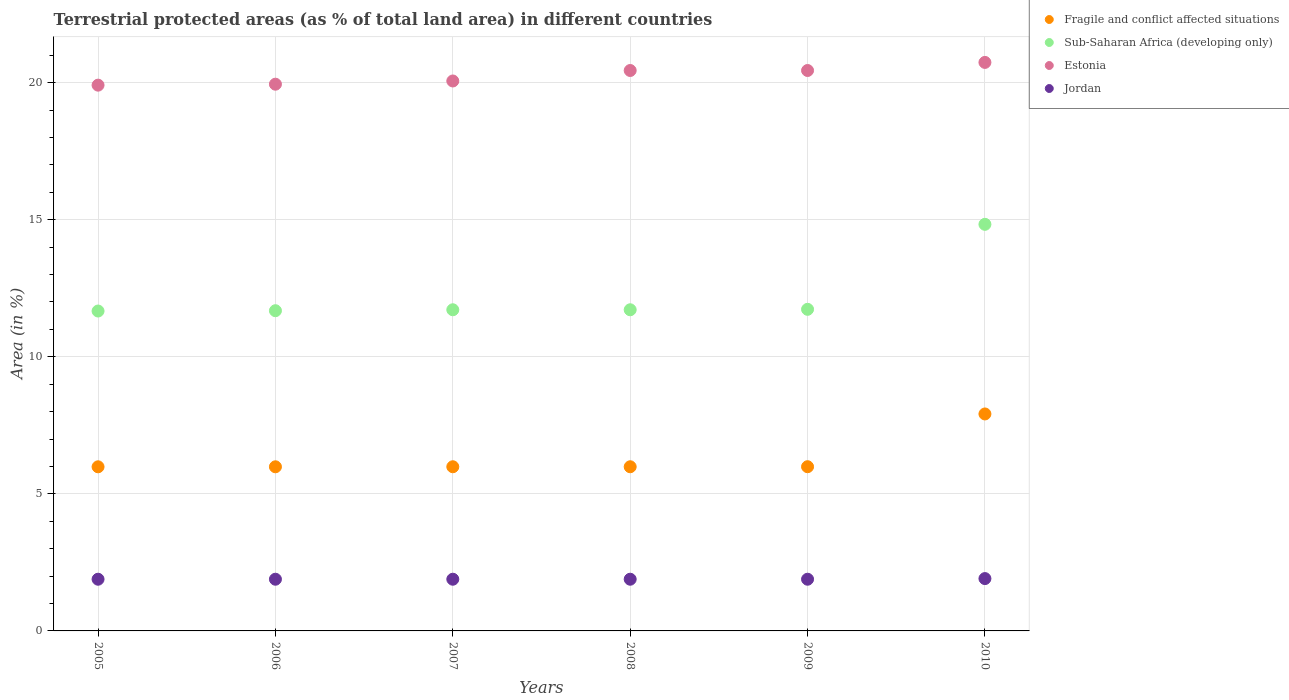How many different coloured dotlines are there?
Provide a succinct answer. 4. What is the percentage of terrestrial protected land in Sub-Saharan Africa (developing only) in 2006?
Ensure brevity in your answer.  11.68. Across all years, what is the maximum percentage of terrestrial protected land in Jordan?
Your answer should be very brief. 1.91. Across all years, what is the minimum percentage of terrestrial protected land in Estonia?
Provide a succinct answer. 19.91. In which year was the percentage of terrestrial protected land in Sub-Saharan Africa (developing only) maximum?
Your response must be concise. 2010. In which year was the percentage of terrestrial protected land in Jordan minimum?
Offer a very short reply. 2005. What is the total percentage of terrestrial protected land in Fragile and conflict affected situations in the graph?
Your answer should be compact. 37.85. What is the difference between the percentage of terrestrial protected land in Sub-Saharan Africa (developing only) in 2006 and that in 2009?
Ensure brevity in your answer.  -0.05. What is the difference between the percentage of terrestrial protected land in Sub-Saharan Africa (developing only) in 2005 and the percentage of terrestrial protected land in Fragile and conflict affected situations in 2009?
Offer a terse response. 5.68. What is the average percentage of terrestrial protected land in Estonia per year?
Offer a very short reply. 20.25. In the year 2008, what is the difference between the percentage of terrestrial protected land in Fragile and conflict affected situations and percentage of terrestrial protected land in Jordan?
Keep it short and to the point. 4.1. In how many years, is the percentage of terrestrial protected land in Fragile and conflict affected situations greater than 20 %?
Your response must be concise. 0. What is the ratio of the percentage of terrestrial protected land in Sub-Saharan Africa (developing only) in 2006 to that in 2009?
Your answer should be very brief. 1. Is the percentage of terrestrial protected land in Jordan in 2006 less than that in 2008?
Your answer should be very brief. No. What is the difference between the highest and the second highest percentage of terrestrial protected land in Fragile and conflict affected situations?
Offer a terse response. 1.92. What is the difference between the highest and the lowest percentage of terrestrial protected land in Jordan?
Your answer should be compact. 0.02. In how many years, is the percentage of terrestrial protected land in Fragile and conflict affected situations greater than the average percentage of terrestrial protected land in Fragile and conflict affected situations taken over all years?
Ensure brevity in your answer.  1. Is the sum of the percentage of terrestrial protected land in Fragile and conflict affected situations in 2009 and 2010 greater than the maximum percentage of terrestrial protected land in Sub-Saharan Africa (developing only) across all years?
Keep it short and to the point. No. Is it the case that in every year, the sum of the percentage of terrestrial protected land in Estonia and percentage of terrestrial protected land in Sub-Saharan Africa (developing only)  is greater than the sum of percentage of terrestrial protected land in Fragile and conflict affected situations and percentage of terrestrial protected land in Jordan?
Ensure brevity in your answer.  Yes. Does the percentage of terrestrial protected land in Fragile and conflict affected situations monotonically increase over the years?
Your answer should be very brief. No. Is the percentage of terrestrial protected land in Jordan strictly greater than the percentage of terrestrial protected land in Sub-Saharan Africa (developing only) over the years?
Offer a very short reply. No. Is the percentage of terrestrial protected land in Fragile and conflict affected situations strictly less than the percentage of terrestrial protected land in Jordan over the years?
Your response must be concise. No. How many years are there in the graph?
Provide a succinct answer. 6. Does the graph contain any zero values?
Ensure brevity in your answer.  No. How many legend labels are there?
Provide a succinct answer. 4. What is the title of the graph?
Your answer should be compact. Terrestrial protected areas (as % of total land area) in different countries. What is the label or title of the Y-axis?
Provide a succinct answer. Area (in %). What is the Area (in %) of Fragile and conflict affected situations in 2005?
Your response must be concise. 5.99. What is the Area (in %) in Sub-Saharan Africa (developing only) in 2005?
Your answer should be compact. 11.67. What is the Area (in %) of Estonia in 2005?
Keep it short and to the point. 19.91. What is the Area (in %) of Jordan in 2005?
Keep it short and to the point. 1.89. What is the Area (in %) in Fragile and conflict affected situations in 2006?
Your answer should be very brief. 5.99. What is the Area (in %) of Sub-Saharan Africa (developing only) in 2006?
Your answer should be very brief. 11.68. What is the Area (in %) in Estonia in 2006?
Your response must be concise. 19.94. What is the Area (in %) in Jordan in 2006?
Provide a short and direct response. 1.89. What is the Area (in %) of Fragile and conflict affected situations in 2007?
Your response must be concise. 5.99. What is the Area (in %) of Sub-Saharan Africa (developing only) in 2007?
Offer a terse response. 11.71. What is the Area (in %) of Estonia in 2007?
Provide a succinct answer. 20.06. What is the Area (in %) of Jordan in 2007?
Your answer should be compact. 1.89. What is the Area (in %) of Fragile and conflict affected situations in 2008?
Offer a terse response. 5.99. What is the Area (in %) of Sub-Saharan Africa (developing only) in 2008?
Your response must be concise. 11.71. What is the Area (in %) of Estonia in 2008?
Give a very brief answer. 20.44. What is the Area (in %) of Jordan in 2008?
Provide a short and direct response. 1.89. What is the Area (in %) in Fragile and conflict affected situations in 2009?
Provide a succinct answer. 5.99. What is the Area (in %) in Sub-Saharan Africa (developing only) in 2009?
Offer a very short reply. 11.73. What is the Area (in %) of Estonia in 2009?
Provide a succinct answer. 20.44. What is the Area (in %) in Jordan in 2009?
Provide a succinct answer. 1.89. What is the Area (in %) of Fragile and conflict affected situations in 2010?
Ensure brevity in your answer.  7.91. What is the Area (in %) in Sub-Saharan Africa (developing only) in 2010?
Your answer should be compact. 14.83. What is the Area (in %) of Estonia in 2010?
Provide a short and direct response. 20.74. What is the Area (in %) in Jordan in 2010?
Your answer should be very brief. 1.91. Across all years, what is the maximum Area (in %) in Fragile and conflict affected situations?
Your answer should be very brief. 7.91. Across all years, what is the maximum Area (in %) of Sub-Saharan Africa (developing only)?
Your answer should be very brief. 14.83. Across all years, what is the maximum Area (in %) of Estonia?
Offer a terse response. 20.74. Across all years, what is the maximum Area (in %) in Jordan?
Offer a terse response. 1.91. Across all years, what is the minimum Area (in %) of Fragile and conflict affected situations?
Your answer should be compact. 5.99. Across all years, what is the minimum Area (in %) in Sub-Saharan Africa (developing only)?
Provide a short and direct response. 11.67. Across all years, what is the minimum Area (in %) of Estonia?
Give a very brief answer. 19.91. Across all years, what is the minimum Area (in %) of Jordan?
Your response must be concise. 1.89. What is the total Area (in %) in Fragile and conflict affected situations in the graph?
Give a very brief answer. 37.85. What is the total Area (in %) in Sub-Saharan Africa (developing only) in the graph?
Give a very brief answer. 73.34. What is the total Area (in %) in Estonia in the graph?
Offer a very short reply. 121.53. What is the total Area (in %) in Jordan in the graph?
Your response must be concise. 11.34. What is the difference between the Area (in %) in Fragile and conflict affected situations in 2005 and that in 2006?
Provide a short and direct response. -0. What is the difference between the Area (in %) in Sub-Saharan Africa (developing only) in 2005 and that in 2006?
Ensure brevity in your answer.  -0.01. What is the difference between the Area (in %) in Estonia in 2005 and that in 2006?
Make the answer very short. -0.03. What is the difference between the Area (in %) of Jordan in 2005 and that in 2006?
Offer a very short reply. 0. What is the difference between the Area (in %) in Fragile and conflict affected situations in 2005 and that in 2007?
Make the answer very short. -0. What is the difference between the Area (in %) of Sub-Saharan Africa (developing only) in 2005 and that in 2007?
Provide a succinct answer. -0.05. What is the difference between the Area (in %) of Estonia in 2005 and that in 2007?
Provide a short and direct response. -0.15. What is the difference between the Area (in %) in Jordan in 2005 and that in 2007?
Keep it short and to the point. 0. What is the difference between the Area (in %) in Fragile and conflict affected situations in 2005 and that in 2008?
Give a very brief answer. -0. What is the difference between the Area (in %) in Sub-Saharan Africa (developing only) in 2005 and that in 2008?
Give a very brief answer. -0.05. What is the difference between the Area (in %) of Estonia in 2005 and that in 2008?
Provide a succinct answer. -0.53. What is the difference between the Area (in %) in Jordan in 2005 and that in 2008?
Ensure brevity in your answer.  0. What is the difference between the Area (in %) in Fragile and conflict affected situations in 2005 and that in 2009?
Give a very brief answer. -0. What is the difference between the Area (in %) in Sub-Saharan Africa (developing only) in 2005 and that in 2009?
Offer a very short reply. -0.06. What is the difference between the Area (in %) of Estonia in 2005 and that in 2009?
Your response must be concise. -0.53. What is the difference between the Area (in %) of Fragile and conflict affected situations in 2005 and that in 2010?
Offer a terse response. -1.93. What is the difference between the Area (in %) of Sub-Saharan Africa (developing only) in 2005 and that in 2010?
Provide a succinct answer. -3.16. What is the difference between the Area (in %) in Estonia in 2005 and that in 2010?
Provide a succinct answer. -0.83. What is the difference between the Area (in %) of Jordan in 2005 and that in 2010?
Your response must be concise. -0.02. What is the difference between the Area (in %) of Fragile and conflict affected situations in 2006 and that in 2007?
Ensure brevity in your answer.  -0. What is the difference between the Area (in %) of Sub-Saharan Africa (developing only) in 2006 and that in 2007?
Offer a terse response. -0.03. What is the difference between the Area (in %) in Estonia in 2006 and that in 2007?
Offer a terse response. -0.12. What is the difference between the Area (in %) of Jordan in 2006 and that in 2007?
Offer a terse response. 0. What is the difference between the Area (in %) in Fragile and conflict affected situations in 2006 and that in 2008?
Make the answer very short. -0. What is the difference between the Area (in %) of Sub-Saharan Africa (developing only) in 2006 and that in 2008?
Your answer should be very brief. -0.03. What is the difference between the Area (in %) in Estonia in 2006 and that in 2008?
Your response must be concise. -0.5. What is the difference between the Area (in %) in Fragile and conflict affected situations in 2006 and that in 2009?
Your answer should be compact. -0. What is the difference between the Area (in %) of Sub-Saharan Africa (developing only) in 2006 and that in 2009?
Your answer should be compact. -0.05. What is the difference between the Area (in %) in Estonia in 2006 and that in 2009?
Your answer should be very brief. -0.5. What is the difference between the Area (in %) in Fragile and conflict affected situations in 2006 and that in 2010?
Offer a very short reply. -1.93. What is the difference between the Area (in %) in Sub-Saharan Africa (developing only) in 2006 and that in 2010?
Keep it short and to the point. -3.15. What is the difference between the Area (in %) in Estonia in 2006 and that in 2010?
Your response must be concise. -0.79. What is the difference between the Area (in %) of Jordan in 2006 and that in 2010?
Your answer should be very brief. -0.02. What is the difference between the Area (in %) in Fragile and conflict affected situations in 2007 and that in 2008?
Offer a very short reply. 0. What is the difference between the Area (in %) of Estonia in 2007 and that in 2008?
Provide a short and direct response. -0.38. What is the difference between the Area (in %) in Fragile and conflict affected situations in 2007 and that in 2009?
Your answer should be compact. -0. What is the difference between the Area (in %) of Sub-Saharan Africa (developing only) in 2007 and that in 2009?
Your answer should be very brief. -0.02. What is the difference between the Area (in %) in Estonia in 2007 and that in 2009?
Offer a very short reply. -0.38. What is the difference between the Area (in %) of Fragile and conflict affected situations in 2007 and that in 2010?
Give a very brief answer. -1.93. What is the difference between the Area (in %) in Sub-Saharan Africa (developing only) in 2007 and that in 2010?
Your answer should be very brief. -3.12. What is the difference between the Area (in %) in Estonia in 2007 and that in 2010?
Keep it short and to the point. -0.68. What is the difference between the Area (in %) in Jordan in 2007 and that in 2010?
Your response must be concise. -0.02. What is the difference between the Area (in %) in Fragile and conflict affected situations in 2008 and that in 2009?
Keep it short and to the point. -0. What is the difference between the Area (in %) in Sub-Saharan Africa (developing only) in 2008 and that in 2009?
Offer a very short reply. -0.02. What is the difference between the Area (in %) in Jordan in 2008 and that in 2009?
Offer a terse response. 0. What is the difference between the Area (in %) of Fragile and conflict affected situations in 2008 and that in 2010?
Offer a very short reply. -1.93. What is the difference between the Area (in %) in Sub-Saharan Africa (developing only) in 2008 and that in 2010?
Provide a succinct answer. -3.12. What is the difference between the Area (in %) of Estonia in 2008 and that in 2010?
Give a very brief answer. -0.29. What is the difference between the Area (in %) in Jordan in 2008 and that in 2010?
Keep it short and to the point. -0.02. What is the difference between the Area (in %) in Fragile and conflict affected situations in 2009 and that in 2010?
Make the answer very short. -1.92. What is the difference between the Area (in %) of Sub-Saharan Africa (developing only) in 2009 and that in 2010?
Your answer should be very brief. -3.1. What is the difference between the Area (in %) in Estonia in 2009 and that in 2010?
Provide a short and direct response. -0.29. What is the difference between the Area (in %) in Jordan in 2009 and that in 2010?
Provide a succinct answer. -0.02. What is the difference between the Area (in %) in Fragile and conflict affected situations in 2005 and the Area (in %) in Sub-Saharan Africa (developing only) in 2006?
Your response must be concise. -5.69. What is the difference between the Area (in %) of Fragile and conflict affected situations in 2005 and the Area (in %) of Estonia in 2006?
Offer a terse response. -13.96. What is the difference between the Area (in %) in Fragile and conflict affected situations in 2005 and the Area (in %) in Jordan in 2006?
Give a very brief answer. 4.1. What is the difference between the Area (in %) in Sub-Saharan Africa (developing only) in 2005 and the Area (in %) in Estonia in 2006?
Provide a short and direct response. -8.27. What is the difference between the Area (in %) in Sub-Saharan Africa (developing only) in 2005 and the Area (in %) in Jordan in 2006?
Ensure brevity in your answer.  9.78. What is the difference between the Area (in %) in Estonia in 2005 and the Area (in %) in Jordan in 2006?
Keep it short and to the point. 18.02. What is the difference between the Area (in %) of Fragile and conflict affected situations in 2005 and the Area (in %) of Sub-Saharan Africa (developing only) in 2007?
Your response must be concise. -5.73. What is the difference between the Area (in %) in Fragile and conflict affected situations in 2005 and the Area (in %) in Estonia in 2007?
Your answer should be compact. -14.07. What is the difference between the Area (in %) in Fragile and conflict affected situations in 2005 and the Area (in %) in Jordan in 2007?
Give a very brief answer. 4.1. What is the difference between the Area (in %) of Sub-Saharan Africa (developing only) in 2005 and the Area (in %) of Estonia in 2007?
Provide a succinct answer. -8.39. What is the difference between the Area (in %) in Sub-Saharan Africa (developing only) in 2005 and the Area (in %) in Jordan in 2007?
Offer a terse response. 9.78. What is the difference between the Area (in %) of Estonia in 2005 and the Area (in %) of Jordan in 2007?
Ensure brevity in your answer.  18.02. What is the difference between the Area (in %) in Fragile and conflict affected situations in 2005 and the Area (in %) in Sub-Saharan Africa (developing only) in 2008?
Give a very brief answer. -5.73. What is the difference between the Area (in %) of Fragile and conflict affected situations in 2005 and the Area (in %) of Estonia in 2008?
Your answer should be very brief. -14.46. What is the difference between the Area (in %) in Fragile and conflict affected situations in 2005 and the Area (in %) in Jordan in 2008?
Ensure brevity in your answer.  4.1. What is the difference between the Area (in %) in Sub-Saharan Africa (developing only) in 2005 and the Area (in %) in Estonia in 2008?
Your response must be concise. -8.77. What is the difference between the Area (in %) of Sub-Saharan Africa (developing only) in 2005 and the Area (in %) of Jordan in 2008?
Provide a short and direct response. 9.78. What is the difference between the Area (in %) of Estonia in 2005 and the Area (in %) of Jordan in 2008?
Your answer should be very brief. 18.02. What is the difference between the Area (in %) of Fragile and conflict affected situations in 2005 and the Area (in %) of Sub-Saharan Africa (developing only) in 2009?
Give a very brief answer. -5.74. What is the difference between the Area (in %) of Fragile and conflict affected situations in 2005 and the Area (in %) of Estonia in 2009?
Offer a terse response. -14.46. What is the difference between the Area (in %) of Fragile and conflict affected situations in 2005 and the Area (in %) of Jordan in 2009?
Ensure brevity in your answer.  4.1. What is the difference between the Area (in %) of Sub-Saharan Africa (developing only) in 2005 and the Area (in %) of Estonia in 2009?
Provide a succinct answer. -8.77. What is the difference between the Area (in %) in Sub-Saharan Africa (developing only) in 2005 and the Area (in %) in Jordan in 2009?
Your answer should be very brief. 9.78. What is the difference between the Area (in %) of Estonia in 2005 and the Area (in %) of Jordan in 2009?
Provide a short and direct response. 18.02. What is the difference between the Area (in %) of Fragile and conflict affected situations in 2005 and the Area (in %) of Sub-Saharan Africa (developing only) in 2010?
Keep it short and to the point. -8.84. What is the difference between the Area (in %) of Fragile and conflict affected situations in 2005 and the Area (in %) of Estonia in 2010?
Offer a terse response. -14.75. What is the difference between the Area (in %) of Fragile and conflict affected situations in 2005 and the Area (in %) of Jordan in 2010?
Ensure brevity in your answer.  4.08. What is the difference between the Area (in %) in Sub-Saharan Africa (developing only) in 2005 and the Area (in %) in Estonia in 2010?
Ensure brevity in your answer.  -9.07. What is the difference between the Area (in %) of Sub-Saharan Africa (developing only) in 2005 and the Area (in %) of Jordan in 2010?
Offer a very short reply. 9.76. What is the difference between the Area (in %) of Estonia in 2005 and the Area (in %) of Jordan in 2010?
Your response must be concise. 18. What is the difference between the Area (in %) of Fragile and conflict affected situations in 2006 and the Area (in %) of Sub-Saharan Africa (developing only) in 2007?
Your answer should be very brief. -5.73. What is the difference between the Area (in %) in Fragile and conflict affected situations in 2006 and the Area (in %) in Estonia in 2007?
Offer a terse response. -14.07. What is the difference between the Area (in %) in Fragile and conflict affected situations in 2006 and the Area (in %) in Jordan in 2007?
Offer a very short reply. 4.1. What is the difference between the Area (in %) in Sub-Saharan Africa (developing only) in 2006 and the Area (in %) in Estonia in 2007?
Your answer should be very brief. -8.38. What is the difference between the Area (in %) in Sub-Saharan Africa (developing only) in 2006 and the Area (in %) in Jordan in 2007?
Your answer should be very brief. 9.79. What is the difference between the Area (in %) of Estonia in 2006 and the Area (in %) of Jordan in 2007?
Give a very brief answer. 18.06. What is the difference between the Area (in %) in Fragile and conflict affected situations in 2006 and the Area (in %) in Sub-Saharan Africa (developing only) in 2008?
Provide a short and direct response. -5.73. What is the difference between the Area (in %) in Fragile and conflict affected situations in 2006 and the Area (in %) in Estonia in 2008?
Keep it short and to the point. -14.46. What is the difference between the Area (in %) in Fragile and conflict affected situations in 2006 and the Area (in %) in Jordan in 2008?
Give a very brief answer. 4.1. What is the difference between the Area (in %) in Sub-Saharan Africa (developing only) in 2006 and the Area (in %) in Estonia in 2008?
Make the answer very short. -8.76. What is the difference between the Area (in %) of Sub-Saharan Africa (developing only) in 2006 and the Area (in %) of Jordan in 2008?
Offer a terse response. 9.79. What is the difference between the Area (in %) of Estonia in 2006 and the Area (in %) of Jordan in 2008?
Make the answer very short. 18.06. What is the difference between the Area (in %) in Fragile and conflict affected situations in 2006 and the Area (in %) in Sub-Saharan Africa (developing only) in 2009?
Give a very brief answer. -5.74. What is the difference between the Area (in %) of Fragile and conflict affected situations in 2006 and the Area (in %) of Estonia in 2009?
Make the answer very short. -14.46. What is the difference between the Area (in %) in Fragile and conflict affected situations in 2006 and the Area (in %) in Jordan in 2009?
Your response must be concise. 4.1. What is the difference between the Area (in %) in Sub-Saharan Africa (developing only) in 2006 and the Area (in %) in Estonia in 2009?
Your response must be concise. -8.76. What is the difference between the Area (in %) of Sub-Saharan Africa (developing only) in 2006 and the Area (in %) of Jordan in 2009?
Provide a succinct answer. 9.79. What is the difference between the Area (in %) in Estonia in 2006 and the Area (in %) in Jordan in 2009?
Your response must be concise. 18.06. What is the difference between the Area (in %) of Fragile and conflict affected situations in 2006 and the Area (in %) of Sub-Saharan Africa (developing only) in 2010?
Your answer should be compact. -8.84. What is the difference between the Area (in %) in Fragile and conflict affected situations in 2006 and the Area (in %) in Estonia in 2010?
Your answer should be compact. -14.75. What is the difference between the Area (in %) of Fragile and conflict affected situations in 2006 and the Area (in %) of Jordan in 2010?
Offer a terse response. 4.08. What is the difference between the Area (in %) in Sub-Saharan Africa (developing only) in 2006 and the Area (in %) in Estonia in 2010?
Your answer should be very brief. -9.06. What is the difference between the Area (in %) in Sub-Saharan Africa (developing only) in 2006 and the Area (in %) in Jordan in 2010?
Keep it short and to the point. 9.77. What is the difference between the Area (in %) in Estonia in 2006 and the Area (in %) in Jordan in 2010?
Offer a terse response. 18.03. What is the difference between the Area (in %) in Fragile and conflict affected situations in 2007 and the Area (in %) in Sub-Saharan Africa (developing only) in 2008?
Offer a terse response. -5.73. What is the difference between the Area (in %) in Fragile and conflict affected situations in 2007 and the Area (in %) in Estonia in 2008?
Your response must be concise. -14.45. What is the difference between the Area (in %) of Fragile and conflict affected situations in 2007 and the Area (in %) of Jordan in 2008?
Your response must be concise. 4.1. What is the difference between the Area (in %) of Sub-Saharan Africa (developing only) in 2007 and the Area (in %) of Estonia in 2008?
Ensure brevity in your answer.  -8.73. What is the difference between the Area (in %) in Sub-Saharan Africa (developing only) in 2007 and the Area (in %) in Jordan in 2008?
Ensure brevity in your answer.  9.83. What is the difference between the Area (in %) in Estonia in 2007 and the Area (in %) in Jordan in 2008?
Offer a very short reply. 18.17. What is the difference between the Area (in %) in Fragile and conflict affected situations in 2007 and the Area (in %) in Sub-Saharan Africa (developing only) in 2009?
Your answer should be very brief. -5.74. What is the difference between the Area (in %) of Fragile and conflict affected situations in 2007 and the Area (in %) of Estonia in 2009?
Your answer should be compact. -14.45. What is the difference between the Area (in %) in Fragile and conflict affected situations in 2007 and the Area (in %) in Jordan in 2009?
Your answer should be very brief. 4.1. What is the difference between the Area (in %) in Sub-Saharan Africa (developing only) in 2007 and the Area (in %) in Estonia in 2009?
Your answer should be very brief. -8.73. What is the difference between the Area (in %) of Sub-Saharan Africa (developing only) in 2007 and the Area (in %) of Jordan in 2009?
Offer a very short reply. 9.83. What is the difference between the Area (in %) of Estonia in 2007 and the Area (in %) of Jordan in 2009?
Offer a terse response. 18.17. What is the difference between the Area (in %) of Fragile and conflict affected situations in 2007 and the Area (in %) of Sub-Saharan Africa (developing only) in 2010?
Provide a short and direct response. -8.84. What is the difference between the Area (in %) of Fragile and conflict affected situations in 2007 and the Area (in %) of Estonia in 2010?
Ensure brevity in your answer.  -14.75. What is the difference between the Area (in %) of Fragile and conflict affected situations in 2007 and the Area (in %) of Jordan in 2010?
Your answer should be very brief. 4.08. What is the difference between the Area (in %) of Sub-Saharan Africa (developing only) in 2007 and the Area (in %) of Estonia in 2010?
Ensure brevity in your answer.  -9.02. What is the difference between the Area (in %) of Sub-Saharan Africa (developing only) in 2007 and the Area (in %) of Jordan in 2010?
Provide a succinct answer. 9.81. What is the difference between the Area (in %) in Estonia in 2007 and the Area (in %) in Jordan in 2010?
Give a very brief answer. 18.15. What is the difference between the Area (in %) of Fragile and conflict affected situations in 2008 and the Area (in %) of Sub-Saharan Africa (developing only) in 2009?
Your answer should be very brief. -5.74. What is the difference between the Area (in %) in Fragile and conflict affected situations in 2008 and the Area (in %) in Estonia in 2009?
Keep it short and to the point. -14.45. What is the difference between the Area (in %) of Fragile and conflict affected situations in 2008 and the Area (in %) of Jordan in 2009?
Keep it short and to the point. 4.1. What is the difference between the Area (in %) of Sub-Saharan Africa (developing only) in 2008 and the Area (in %) of Estonia in 2009?
Keep it short and to the point. -8.73. What is the difference between the Area (in %) in Sub-Saharan Africa (developing only) in 2008 and the Area (in %) in Jordan in 2009?
Your answer should be compact. 9.83. What is the difference between the Area (in %) in Estonia in 2008 and the Area (in %) in Jordan in 2009?
Offer a terse response. 18.56. What is the difference between the Area (in %) of Fragile and conflict affected situations in 2008 and the Area (in %) of Sub-Saharan Africa (developing only) in 2010?
Give a very brief answer. -8.84. What is the difference between the Area (in %) of Fragile and conflict affected situations in 2008 and the Area (in %) of Estonia in 2010?
Give a very brief answer. -14.75. What is the difference between the Area (in %) of Fragile and conflict affected situations in 2008 and the Area (in %) of Jordan in 2010?
Provide a short and direct response. 4.08. What is the difference between the Area (in %) of Sub-Saharan Africa (developing only) in 2008 and the Area (in %) of Estonia in 2010?
Your response must be concise. -9.02. What is the difference between the Area (in %) in Sub-Saharan Africa (developing only) in 2008 and the Area (in %) in Jordan in 2010?
Your response must be concise. 9.81. What is the difference between the Area (in %) of Estonia in 2008 and the Area (in %) of Jordan in 2010?
Keep it short and to the point. 18.53. What is the difference between the Area (in %) of Fragile and conflict affected situations in 2009 and the Area (in %) of Sub-Saharan Africa (developing only) in 2010?
Make the answer very short. -8.84. What is the difference between the Area (in %) in Fragile and conflict affected situations in 2009 and the Area (in %) in Estonia in 2010?
Provide a succinct answer. -14.75. What is the difference between the Area (in %) in Fragile and conflict affected situations in 2009 and the Area (in %) in Jordan in 2010?
Ensure brevity in your answer.  4.08. What is the difference between the Area (in %) of Sub-Saharan Africa (developing only) in 2009 and the Area (in %) of Estonia in 2010?
Your response must be concise. -9.01. What is the difference between the Area (in %) of Sub-Saharan Africa (developing only) in 2009 and the Area (in %) of Jordan in 2010?
Keep it short and to the point. 9.82. What is the difference between the Area (in %) of Estonia in 2009 and the Area (in %) of Jordan in 2010?
Keep it short and to the point. 18.53. What is the average Area (in %) in Fragile and conflict affected situations per year?
Provide a succinct answer. 6.31. What is the average Area (in %) of Sub-Saharan Africa (developing only) per year?
Your response must be concise. 12.22. What is the average Area (in %) of Estonia per year?
Ensure brevity in your answer.  20.25. What is the average Area (in %) in Jordan per year?
Give a very brief answer. 1.89. In the year 2005, what is the difference between the Area (in %) of Fragile and conflict affected situations and Area (in %) of Sub-Saharan Africa (developing only)?
Ensure brevity in your answer.  -5.68. In the year 2005, what is the difference between the Area (in %) in Fragile and conflict affected situations and Area (in %) in Estonia?
Your answer should be very brief. -13.92. In the year 2005, what is the difference between the Area (in %) in Fragile and conflict affected situations and Area (in %) in Jordan?
Provide a succinct answer. 4.1. In the year 2005, what is the difference between the Area (in %) of Sub-Saharan Africa (developing only) and Area (in %) of Estonia?
Keep it short and to the point. -8.24. In the year 2005, what is the difference between the Area (in %) in Sub-Saharan Africa (developing only) and Area (in %) in Jordan?
Keep it short and to the point. 9.78. In the year 2005, what is the difference between the Area (in %) in Estonia and Area (in %) in Jordan?
Offer a very short reply. 18.02. In the year 2006, what is the difference between the Area (in %) of Fragile and conflict affected situations and Area (in %) of Sub-Saharan Africa (developing only)?
Ensure brevity in your answer.  -5.69. In the year 2006, what is the difference between the Area (in %) in Fragile and conflict affected situations and Area (in %) in Estonia?
Ensure brevity in your answer.  -13.96. In the year 2006, what is the difference between the Area (in %) of Fragile and conflict affected situations and Area (in %) of Jordan?
Ensure brevity in your answer.  4.1. In the year 2006, what is the difference between the Area (in %) in Sub-Saharan Africa (developing only) and Area (in %) in Estonia?
Keep it short and to the point. -8.26. In the year 2006, what is the difference between the Area (in %) in Sub-Saharan Africa (developing only) and Area (in %) in Jordan?
Provide a short and direct response. 9.79. In the year 2006, what is the difference between the Area (in %) in Estonia and Area (in %) in Jordan?
Ensure brevity in your answer.  18.06. In the year 2007, what is the difference between the Area (in %) of Fragile and conflict affected situations and Area (in %) of Sub-Saharan Africa (developing only)?
Offer a terse response. -5.73. In the year 2007, what is the difference between the Area (in %) in Fragile and conflict affected situations and Area (in %) in Estonia?
Your response must be concise. -14.07. In the year 2007, what is the difference between the Area (in %) in Fragile and conflict affected situations and Area (in %) in Jordan?
Your answer should be very brief. 4.1. In the year 2007, what is the difference between the Area (in %) of Sub-Saharan Africa (developing only) and Area (in %) of Estonia?
Your response must be concise. -8.35. In the year 2007, what is the difference between the Area (in %) in Sub-Saharan Africa (developing only) and Area (in %) in Jordan?
Your response must be concise. 9.83. In the year 2007, what is the difference between the Area (in %) of Estonia and Area (in %) of Jordan?
Your answer should be compact. 18.17. In the year 2008, what is the difference between the Area (in %) in Fragile and conflict affected situations and Area (in %) in Sub-Saharan Africa (developing only)?
Ensure brevity in your answer.  -5.73. In the year 2008, what is the difference between the Area (in %) in Fragile and conflict affected situations and Area (in %) in Estonia?
Offer a very short reply. -14.45. In the year 2008, what is the difference between the Area (in %) of Fragile and conflict affected situations and Area (in %) of Jordan?
Ensure brevity in your answer.  4.1. In the year 2008, what is the difference between the Area (in %) of Sub-Saharan Africa (developing only) and Area (in %) of Estonia?
Provide a succinct answer. -8.73. In the year 2008, what is the difference between the Area (in %) of Sub-Saharan Africa (developing only) and Area (in %) of Jordan?
Ensure brevity in your answer.  9.83. In the year 2008, what is the difference between the Area (in %) in Estonia and Area (in %) in Jordan?
Give a very brief answer. 18.56. In the year 2009, what is the difference between the Area (in %) in Fragile and conflict affected situations and Area (in %) in Sub-Saharan Africa (developing only)?
Your response must be concise. -5.74. In the year 2009, what is the difference between the Area (in %) in Fragile and conflict affected situations and Area (in %) in Estonia?
Provide a short and direct response. -14.45. In the year 2009, what is the difference between the Area (in %) in Fragile and conflict affected situations and Area (in %) in Jordan?
Provide a short and direct response. 4.1. In the year 2009, what is the difference between the Area (in %) in Sub-Saharan Africa (developing only) and Area (in %) in Estonia?
Your response must be concise. -8.71. In the year 2009, what is the difference between the Area (in %) of Sub-Saharan Africa (developing only) and Area (in %) of Jordan?
Make the answer very short. 9.85. In the year 2009, what is the difference between the Area (in %) in Estonia and Area (in %) in Jordan?
Offer a very short reply. 18.56. In the year 2010, what is the difference between the Area (in %) in Fragile and conflict affected situations and Area (in %) in Sub-Saharan Africa (developing only)?
Provide a succinct answer. -6.92. In the year 2010, what is the difference between the Area (in %) in Fragile and conflict affected situations and Area (in %) in Estonia?
Give a very brief answer. -12.82. In the year 2010, what is the difference between the Area (in %) in Fragile and conflict affected situations and Area (in %) in Jordan?
Your answer should be very brief. 6. In the year 2010, what is the difference between the Area (in %) in Sub-Saharan Africa (developing only) and Area (in %) in Estonia?
Offer a very short reply. -5.91. In the year 2010, what is the difference between the Area (in %) of Sub-Saharan Africa (developing only) and Area (in %) of Jordan?
Ensure brevity in your answer.  12.92. In the year 2010, what is the difference between the Area (in %) in Estonia and Area (in %) in Jordan?
Provide a short and direct response. 18.83. What is the ratio of the Area (in %) in Fragile and conflict affected situations in 2005 to that in 2006?
Keep it short and to the point. 1. What is the ratio of the Area (in %) of Jordan in 2005 to that in 2006?
Make the answer very short. 1. What is the ratio of the Area (in %) in Fragile and conflict affected situations in 2005 to that in 2007?
Your response must be concise. 1. What is the ratio of the Area (in %) in Sub-Saharan Africa (developing only) in 2005 to that in 2007?
Offer a terse response. 1. What is the ratio of the Area (in %) in Jordan in 2005 to that in 2007?
Your answer should be very brief. 1. What is the ratio of the Area (in %) of Sub-Saharan Africa (developing only) in 2005 to that in 2008?
Make the answer very short. 1. What is the ratio of the Area (in %) of Estonia in 2005 to that in 2008?
Provide a succinct answer. 0.97. What is the ratio of the Area (in %) in Fragile and conflict affected situations in 2005 to that in 2009?
Give a very brief answer. 1. What is the ratio of the Area (in %) in Estonia in 2005 to that in 2009?
Give a very brief answer. 0.97. What is the ratio of the Area (in %) of Fragile and conflict affected situations in 2005 to that in 2010?
Provide a short and direct response. 0.76. What is the ratio of the Area (in %) in Sub-Saharan Africa (developing only) in 2005 to that in 2010?
Give a very brief answer. 0.79. What is the ratio of the Area (in %) in Estonia in 2005 to that in 2010?
Offer a very short reply. 0.96. What is the ratio of the Area (in %) of Jordan in 2005 to that in 2010?
Offer a very short reply. 0.99. What is the ratio of the Area (in %) of Jordan in 2006 to that in 2007?
Ensure brevity in your answer.  1. What is the ratio of the Area (in %) in Estonia in 2006 to that in 2008?
Your answer should be compact. 0.98. What is the ratio of the Area (in %) in Estonia in 2006 to that in 2009?
Provide a short and direct response. 0.98. What is the ratio of the Area (in %) of Fragile and conflict affected situations in 2006 to that in 2010?
Provide a succinct answer. 0.76. What is the ratio of the Area (in %) in Sub-Saharan Africa (developing only) in 2006 to that in 2010?
Offer a terse response. 0.79. What is the ratio of the Area (in %) of Estonia in 2006 to that in 2010?
Make the answer very short. 0.96. What is the ratio of the Area (in %) of Fragile and conflict affected situations in 2007 to that in 2008?
Offer a terse response. 1. What is the ratio of the Area (in %) in Estonia in 2007 to that in 2008?
Ensure brevity in your answer.  0.98. What is the ratio of the Area (in %) in Sub-Saharan Africa (developing only) in 2007 to that in 2009?
Provide a succinct answer. 1. What is the ratio of the Area (in %) of Estonia in 2007 to that in 2009?
Provide a succinct answer. 0.98. What is the ratio of the Area (in %) of Fragile and conflict affected situations in 2007 to that in 2010?
Offer a very short reply. 0.76. What is the ratio of the Area (in %) of Sub-Saharan Africa (developing only) in 2007 to that in 2010?
Make the answer very short. 0.79. What is the ratio of the Area (in %) of Estonia in 2007 to that in 2010?
Ensure brevity in your answer.  0.97. What is the ratio of the Area (in %) in Jordan in 2007 to that in 2010?
Your response must be concise. 0.99. What is the ratio of the Area (in %) of Fragile and conflict affected situations in 2008 to that in 2009?
Provide a succinct answer. 1. What is the ratio of the Area (in %) of Fragile and conflict affected situations in 2008 to that in 2010?
Your answer should be very brief. 0.76. What is the ratio of the Area (in %) of Sub-Saharan Africa (developing only) in 2008 to that in 2010?
Your answer should be compact. 0.79. What is the ratio of the Area (in %) in Estonia in 2008 to that in 2010?
Give a very brief answer. 0.99. What is the ratio of the Area (in %) of Fragile and conflict affected situations in 2009 to that in 2010?
Offer a terse response. 0.76. What is the ratio of the Area (in %) in Sub-Saharan Africa (developing only) in 2009 to that in 2010?
Provide a succinct answer. 0.79. What is the ratio of the Area (in %) in Estonia in 2009 to that in 2010?
Offer a terse response. 0.99. What is the difference between the highest and the second highest Area (in %) of Fragile and conflict affected situations?
Ensure brevity in your answer.  1.92. What is the difference between the highest and the second highest Area (in %) of Sub-Saharan Africa (developing only)?
Offer a terse response. 3.1. What is the difference between the highest and the second highest Area (in %) of Estonia?
Keep it short and to the point. 0.29. What is the difference between the highest and the second highest Area (in %) in Jordan?
Offer a very short reply. 0.02. What is the difference between the highest and the lowest Area (in %) of Fragile and conflict affected situations?
Offer a very short reply. 1.93. What is the difference between the highest and the lowest Area (in %) in Sub-Saharan Africa (developing only)?
Provide a short and direct response. 3.16. What is the difference between the highest and the lowest Area (in %) in Estonia?
Provide a succinct answer. 0.83. What is the difference between the highest and the lowest Area (in %) of Jordan?
Your answer should be very brief. 0.02. 